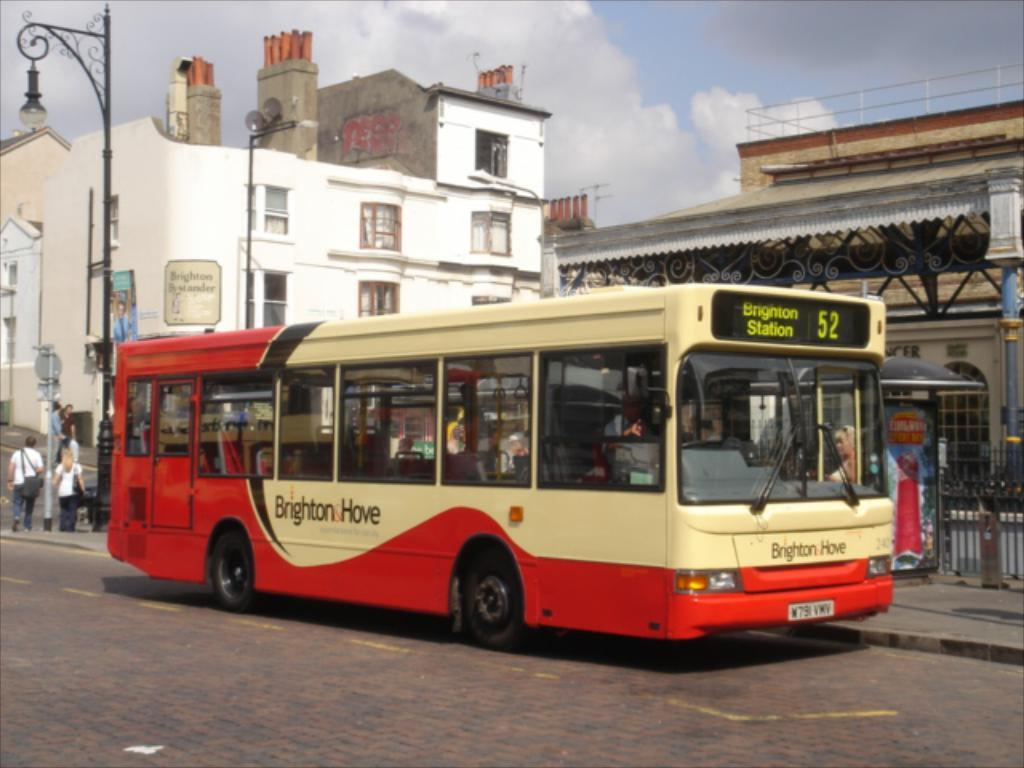Provide a one-sentence caption for the provided image. a bus with the sign of brigton hove on a side. 